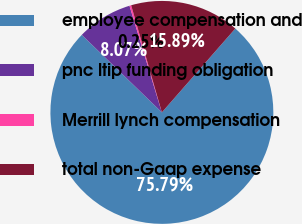Convert chart to OTSL. <chart><loc_0><loc_0><loc_500><loc_500><pie_chart><fcel>employee compensation and<fcel>pnc ltip funding obligation<fcel>Merrill lynch compensation<fcel>total non-Gaap expense<nl><fcel>75.79%<fcel>8.07%<fcel>0.25%<fcel>15.89%<nl></chart> 